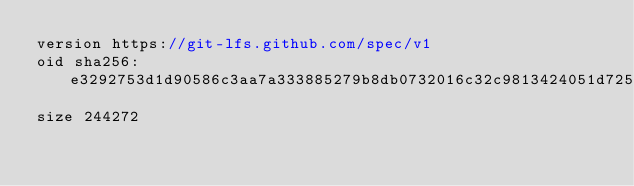<code> <loc_0><loc_0><loc_500><loc_500><_JavaScript_>version https://git-lfs.github.com/spec/v1
oid sha256:e3292753d1d90586c3aa7a333885279b8db0732016c32c9813424051d7251abb
size 244272
</code> 